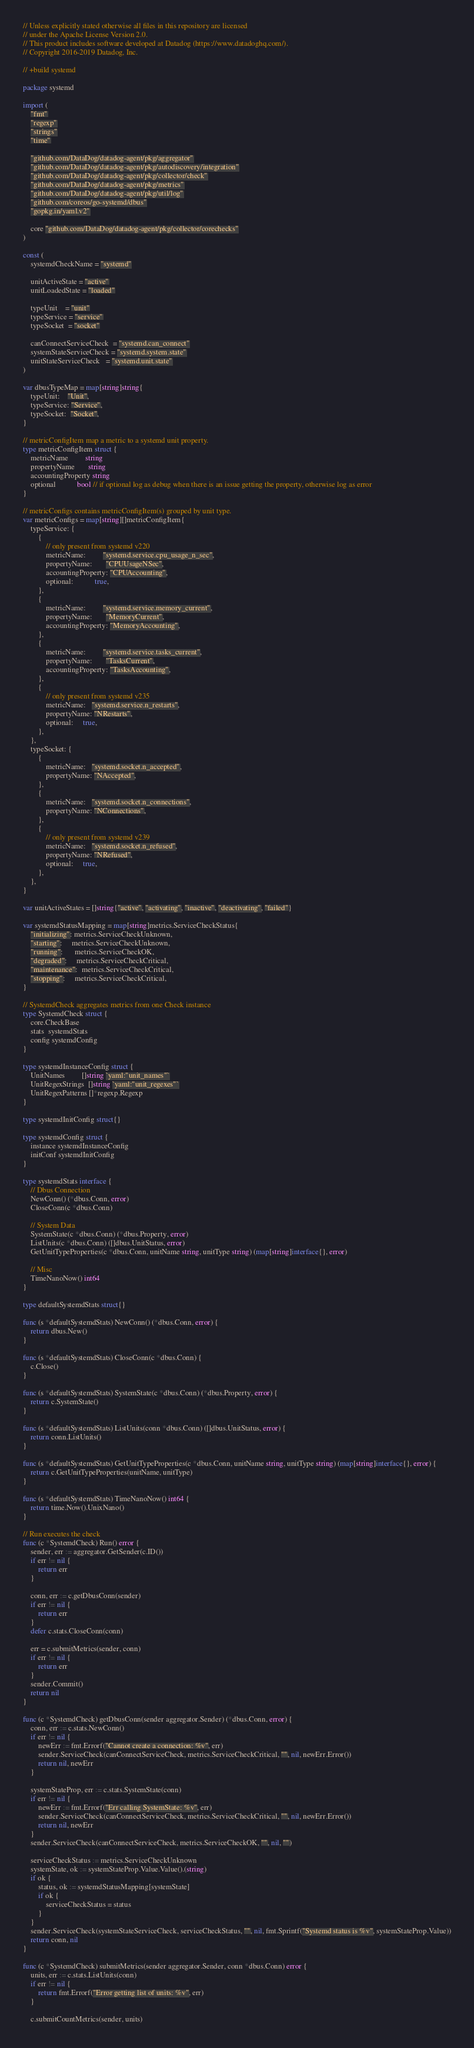<code> <loc_0><loc_0><loc_500><loc_500><_Go_>// Unless explicitly stated otherwise all files in this repository are licensed
// under the Apache License Version 2.0.
// This product includes software developed at Datadog (https://www.datadoghq.com/).
// Copyright 2016-2019 Datadog, Inc.

// +build systemd

package systemd

import (
	"fmt"
	"regexp"
	"strings"
	"time"

	"github.com/DataDog/datadog-agent/pkg/aggregator"
	"github.com/DataDog/datadog-agent/pkg/autodiscovery/integration"
	"github.com/DataDog/datadog-agent/pkg/collector/check"
	"github.com/DataDog/datadog-agent/pkg/metrics"
	"github.com/DataDog/datadog-agent/pkg/util/log"
	"github.com/coreos/go-systemd/dbus"
	"gopkg.in/yaml.v2"

	core "github.com/DataDog/datadog-agent/pkg/collector/corechecks"
)

const (
	systemdCheckName = "systemd"

	unitActiveState = "active"
	unitLoadedState = "loaded"

	typeUnit    = "unit"
	typeService = "service"
	typeSocket  = "socket"

	canConnectServiceCheck  = "systemd.can_connect"
	systemStateServiceCheck = "systemd.system.state"
	unitStateServiceCheck   = "systemd.unit.state"
)

var dbusTypeMap = map[string]string{
	typeUnit:    "Unit",
	typeService: "Service",
	typeSocket:  "Socket",
}

// metricConfigItem map a metric to a systemd unit property.
type metricConfigItem struct {
	metricName         string
	propertyName       string
	accountingProperty string
	optional           bool // if optional log as debug when there is an issue getting the property, otherwise log as error
}

// metricConfigs contains metricConfigItem(s) grouped by unit type.
var metricConfigs = map[string][]metricConfigItem{
	typeService: {
		{
			// only present from systemd v220
			metricName:         "systemd.service.cpu_usage_n_sec",
			propertyName:       "CPUUsageNSec",
			accountingProperty: "CPUAccounting",
			optional:           true,
		},
		{
			metricName:         "systemd.service.memory_current",
			propertyName:       "MemoryCurrent",
			accountingProperty: "MemoryAccounting",
		},
		{
			metricName:         "systemd.service.tasks_current",
			propertyName:       "TasksCurrent",
			accountingProperty: "TasksAccounting",
		},
		{
			// only present from systemd v235
			metricName:   "systemd.service.n_restarts",
			propertyName: "NRestarts",
			optional:     true,
		},
	},
	typeSocket: {
		{
			metricName:   "systemd.socket.n_accepted",
			propertyName: "NAccepted",
		},
		{
			metricName:   "systemd.socket.n_connections",
			propertyName: "NConnections",
		},
		{
			// only present from systemd v239
			metricName:   "systemd.socket.n_refused",
			propertyName: "NRefused",
			optional:     true,
		},
	},
}

var unitActiveStates = []string{"active", "activating", "inactive", "deactivating", "failed"}

var systemdStatusMapping = map[string]metrics.ServiceCheckStatus{
	"initializing": metrics.ServiceCheckUnknown,
	"starting":     metrics.ServiceCheckUnknown,
	"running":      metrics.ServiceCheckOK,
	"degraded":     metrics.ServiceCheckCritical,
	"maintenance":  metrics.ServiceCheckCritical,
	"stopping":     metrics.ServiceCheckCritical,
}

// SystemdCheck aggregates metrics from one Check instance
type SystemdCheck struct {
	core.CheckBase
	stats  systemdStats
	config systemdConfig
}

type systemdInstanceConfig struct {
	UnitNames         []string `yaml:"unit_names"`
	UnitRegexStrings  []string `yaml:"unit_regexes"`
	UnitRegexPatterns []*regexp.Regexp
}

type systemdInitConfig struct{}

type systemdConfig struct {
	instance systemdInstanceConfig
	initConf systemdInitConfig
}

type systemdStats interface {
	// Dbus Connection
	NewConn() (*dbus.Conn, error)
	CloseConn(c *dbus.Conn)

	// System Data
	SystemState(c *dbus.Conn) (*dbus.Property, error)
	ListUnits(c *dbus.Conn) ([]dbus.UnitStatus, error)
	GetUnitTypeProperties(c *dbus.Conn, unitName string, unitType string) (map[string]interface{}, error)

	// Misc
	TimeNanoNow() int64
}

type defaultSystemdStats struct{}

func (s *defaultSystemdStats) NewConn() (*dbus.Conn, error) {
	return dbus.New()
}

func (s *defaultSystemdStats) CloseConn(c *dbus.Conn) {
	c.Close()
}

func (s *defaultSystemdStats) SystemState(c *dbus.Conn) (*dbus.Property, error) {
	return c.SystemState()
}

func (s *defaultSystemdStats) ListUnits(conn *dbus.Conn) ([]dbus.UnitStatus, error) {
	return conn.ListUnits()
}

func (s *defaultSystemdStats) GetUnitTypeProperties(c *dbus.Conn, unitName string, unitType string) (map[string]interface{}, error) {
	return c.GetUnitTypeProperties(unitName, unitType)
}

func (s *defaultSystemdStats) TimeNanoNow() int64 {
	return time.Now().UnixNano()
}

// Run executes the check
func (c *SystemdCheck) Run() error {
	sender, err := aggregator.GetSender(c.ID())
	if err != nil {
		return err
	}

	conn, err := c.getDbusConn(sender)
	if err != nil {
		return err
	}
	defer c.stats.CloseConn(conn)

	err = c.submitMetrics(sender, conn)
	if err != nil {
		return err
	}
	sender.Commit()
	return nil
}

func (c *SystemdCheck) getDbusConn(sender aggregator.Sender) (*dbus.Conn, error) {
	conn, err := c.stats.NewConn()
	if err != nil {
		newErr := fmt.Errorf("Cannot create a connection: %v", err)
		sender.ServiceCheck(canConnectServiceCheck, metrics.ServiceCheckCritical, "", nil, newErr.Error())
		return nil, newErr
	}

	systemStateProp, err := c.stats.SystemState(conn)
	if err != nil {
		newErr := fmt.Errorf("Err calling SystemState: %v", err)
		sender.ServiceCheck(canConnectServiceCheck, metrics.ServiceCheckCritical, "", nil, newErr.Error())
		return nil, newErr
	}
	sender.ServiceCheck(canConnectServiceCheck, metrics.ServiceCheckOK, "", nil, "")

	serviceCheckStatus := metrics.ServiceCheckUnknown
	systemState, ok := systemStateProp.Value.Value().(string)
	if ok {
		status, ok := systemdStatusMapping[systemState]
		if ok {
			serviceCheckStatus = status
		}
	}
	sender.ServiceCheck(systemStateServiceCheck, serviceCheckStatus, "", nil, fmt.Sprintf("Systemd status is %v", systemStateProp.Value))
	return conn, nil
}

func (c *SystemdCheck) submitMetrics(sender aggregator.Sender, conn *dbus.Conn) error {
	units, err := c.stats.ListUnits(conn)
	if err != nil {
		return fmt.Errorf("Error getting list of units: %v", err)
	}

	c.submitCountMetrics(sender, units)
</code> 